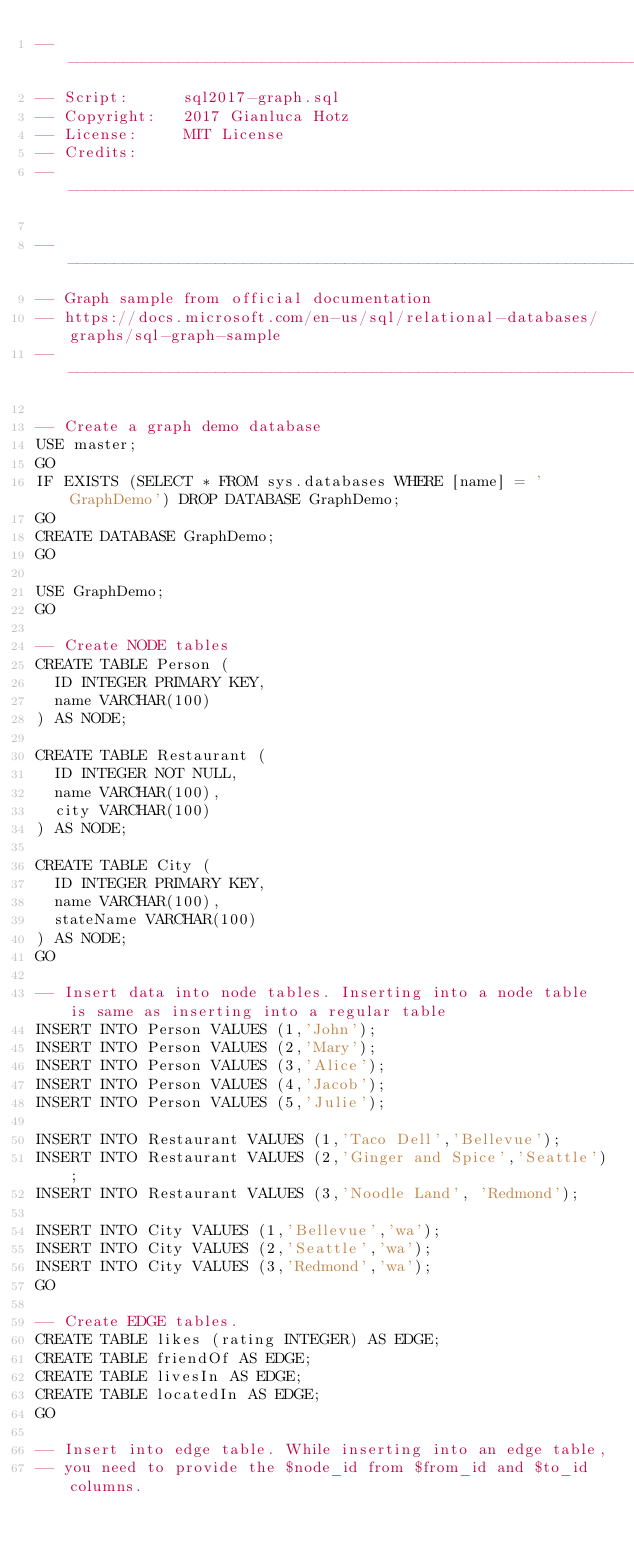Convert code to text. <code><loc_0><loc_0><loc_500><loc_500><_SQL_>------------------------------------------------------------------------
-- Script:		sql2017-graph.sql
-- Copyright:	2017 Gianluca Hotz
-- License:		MIT License
-- Credits:
------------------------------------------------------------------------

------------------------------------------------------------------------
-- Graph sample from official documentation
-- https://docs.microsoft.com/en-us/sql/relational-databases/graphs/sql-graph-sample
------------------------------------------------------------------------

-- Create a graph demo database
USE master;
GO
IF EXISTS (SELECT * FROM sys.databases WHERE [name] = 'GraphDemo') DROP DATABASE GraphDemo;
GO
CREATE DATABASE GraphDemo;
GO

USE GraphDemo;
GO

-- Create NODE tables
CREATE TABLE Person (
  ID INTEGER PRIMARY KEY, 
  name VARCHAR(100)
) AS NODE;

CREATE TABLE Restaurant (
  ID INTEGER NOT NULL, 
  name VARCHAR(100), 
  city VARCHAR(100)
) AS NODE;

CREATE TABLE City (
  ID INTEGER PRIMARY KEY, 
  name VARCHAR(100), 
  stateName VARCHAR(100)
) AS NODE;
GO

-- Insert data into node tables. Inserting into a node table is same as inserting into a regular table
INSERT INTO Person VALUES (1,'John');
INSERT INTO Person VALUES (2,'Mary');
INSERT INTO Person VALUES (3,'Alice');
INSERT INTO Person VALUES (4,'Jacob');
INSERT INTO Person VALUES (5,'Julie');

INSERT INTO Restaurant VALUES (1,'Taco Dell','Bellevue');
INSERT INTO Restaurant VALUES (2,'Ginger and Spice','Seattle');
INSERT INTO Restaurant VALUES (3,'Noodle Land', 'Redmond');

INSERT INTO City VALUES (1,'Bellevue','wa');
INSERT INTO City VALUES (2,'Seattle','wa');
INSERT INTO City VALUES (3,'Redmond','wa');
GO

-- Create EDGE tables. 
CREATE TABLE likes (rating INTEGER) AS EDGE;
CREATE TABLE friendOf AS EDGE;
CREATE TABLE livesIn AS EDGE;
CREATE TABLE locatedIn AS EDGE;
GO

-- Insert into edge table. While inserting into an edge table, 
-- you need to provide the $node_id from $from_id and $to_id columns.</code> 